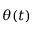Convert formula to latex. <formula><loc_0><loc_0><loc_500><loc_500>\theta ( t )</formula> 